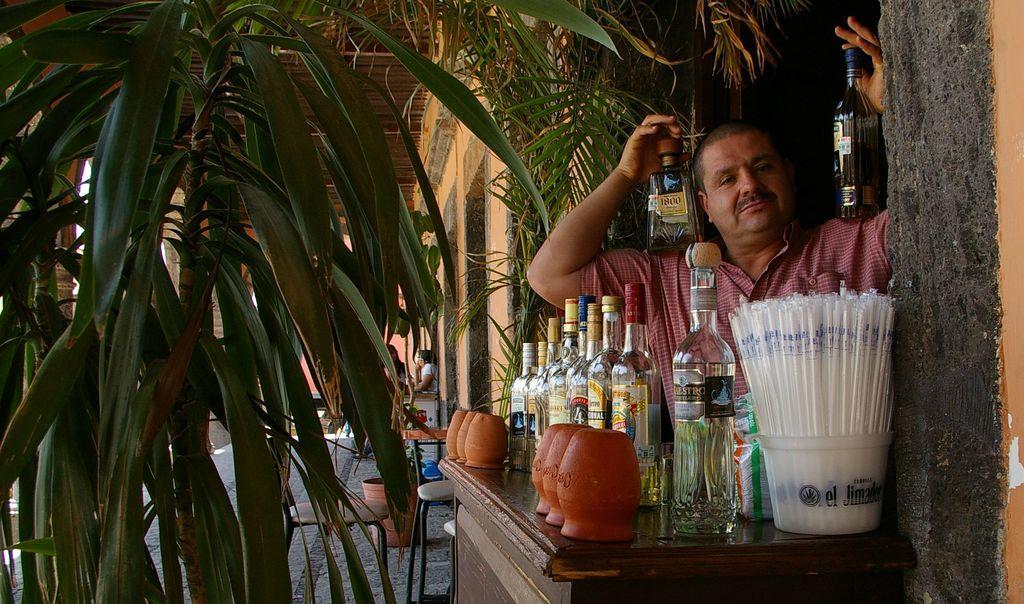How would you summarize this image in a sentence or two? This picture is clicked outside. On the right there is a man wearing a shirt and holding two bottles and we can see the bottles and some items are placed on the top of the wooden cabinet. On the left we can see the tree, roof, a person, chairs and some other objects. 